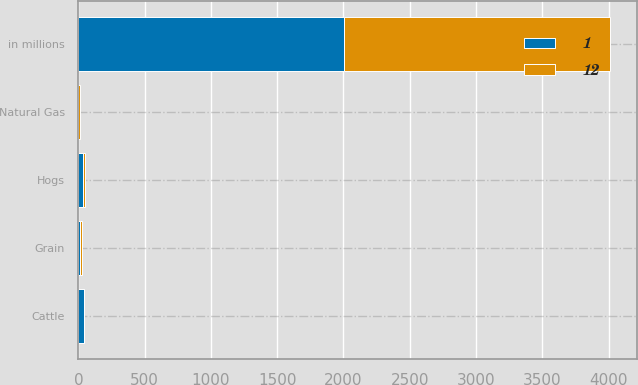<chart> <loc_0><loc_0><loc_500><loc_500><stacked_bar_chart><ecel><fcel>in millions<fcel>Cattle<fcel>Hogs<fcel>Grain<fcel>Natural Gas<nl><fcel>1<fcel>2006<fcel>43<fcel>37<fcel>11<fcel>1<nl><fcel>12<fcel>2005<fcel>3<fcel>13<fcel>15<fcel>12<nl></chart> 